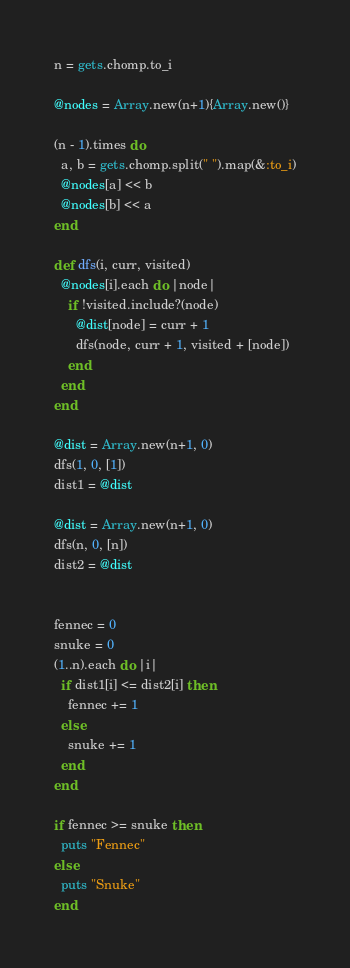Convert code to text. <code><loc_0><loc_0><loc_500><loc_500><_Ruby_>n = gets.chomp.to_i

@nodes = Array.new(n+1){Array.new()}

(n - 1).times do
  a, b = gets.chomp.split(" ").map(&:to_i)
  @nodes[a] << b
  @nodes[b] << a
end

def dfs(i, curr, visited)
  @nodes[i].each do |node|
    if !visited.include?(node)
      @dist[node] = curr + 1
      dfs(node, curr + 1, visited + [node])
    end
  end
end

@dist = Array.new(n+1, 0)
dfs(1, 0, [1])
dist1 = @dist

@dist = Array.new(n+1, 0)
dfs(n, 0, [n])
dist2 = @dist


fennec = 0
snuke = 0
(1..n).each do |i|
  if dist1[i] <= dist2[i] then
    fennec += 1
  else
    snuke += 1
  end
end

if fennec >= snuke then
  puts "Fennec"
else
  puts "Snuke"
end
</code> 